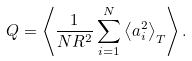<formula> <loc_0><loc_0><loc_500><loc_500>Q = \left \langle \frac { 1 } { N R ^ { 2 } } \sum _ { i = 1 } ^ { N } \left \langle a _ { i } ^ { 2 } \right \rangle _ { T } \right \rangle .</formula> 